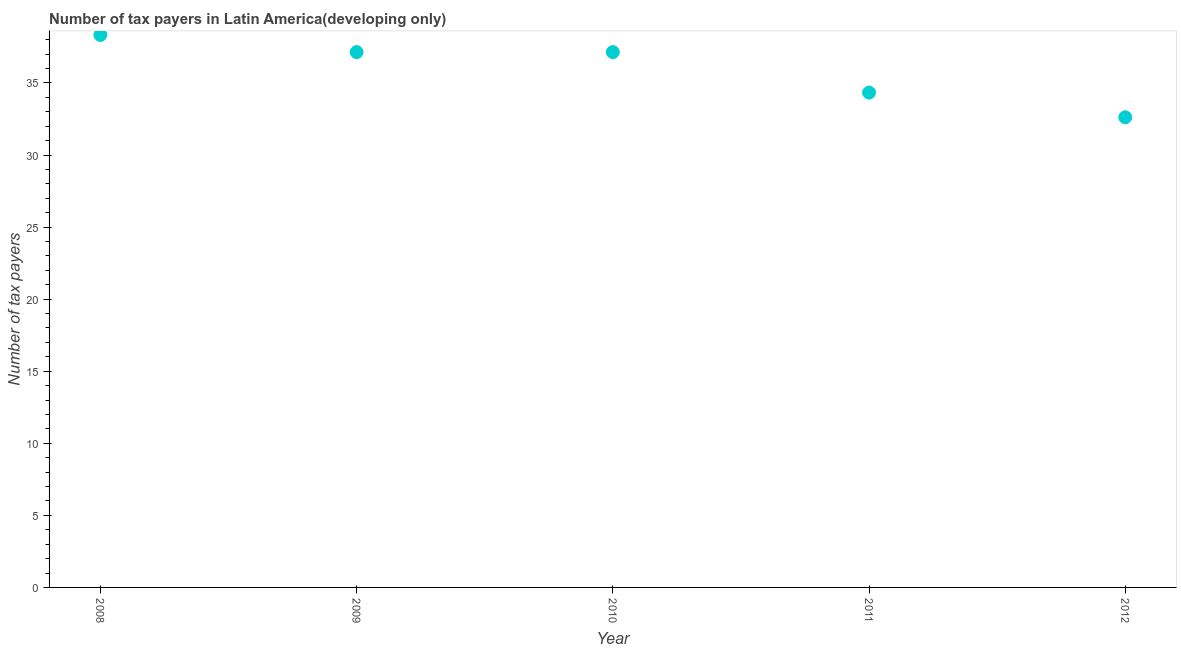What is the number of tax payers in 2012?
Provide a short and direct response. 32.62. Across all years, what is the maximum number of tax payers?
Your answer should be very brief. 38.33. Across all years, what is the minimum number of tax payers?
Keep it short and to the point. 32.62. In which year was the number of tax payers maximum?
Offer a terse response. 2008. In which year was the number of tax payers minimum?
Make the answer very short. 2012. What is the sum of the number of tax payers?
Provide a short and direct response. 179.57. What is the difference between the number of tax payers in 2009 and 2012?
Make the answer very short. 4.52. What is the average number of tax payers per year?
Provide a short and direct response. 35.91. What is the median number of tax payers?
Your answer should be very brief. 37.14. Do a majority of the years between 2012 and 2011 (inclusive) have number of tax payers greater than 10 ?
Your answer should be compact. No. What is the ratio of the number of tax payers in 2008 to that in 2012?
Your answer should be compact. 1.18. Is the difference between the number of tax payers in 2009 and 2012 greater than the difference between any two years?
Your answer should be very brief. No. What is the difference between the highest and the second highest number of tax payers?
Offer a very short reply. 1.19. Is the sum of the number of tax payers in 2008 and 2010 greater than the maximum number of tax payers across all years?
Ensure brevity in your answer.  Yes. What is the difference between the highest and the lowest number of tax payers?
Offer a very short reply. 5.71. In how many years, is the number of tax payers greater than the average number of tax payers taken over all years?
Your response must be concise. 3. How many dotlines are there?
Provide a short and direct response. 1. Does the graph contain any zero values?
Offer a terse response. No. What is the title of the graph?
Your response must be concise. Number of tax payers in Latin America(developing only). What is the label or title of the X-axis?
Your answer should be compact. Year. What is the label or title of the Y-axis?
Your answer should be compact. Number of tax payers. What is the Number of tax payers in 2008?
Your response must be concise. 38.33. What is the Number of tax payers in 2009?
Provide a succinct answer. 37.14. What is the Number of tax payers in 2010?
Provide a short and direct response. 37.14. What is the Number of tax payers in 2011?
Your answer should be compact. 34.33. What is the Number of tax payers in 2012?
Your response must be concise. 32.62. What is the difference between the Number of tax payers in 2008 and 2009?
Ensure brevity in your answer.  1.19. What is the difference between the Number of tax payers in 2008 and 2010?
Ensure brevity in your answer.  1.19. What is the difference between the Number of tax payers in 2008 and 2012?
Keep it short and to the point. 5.71. What is the difference between the Number of tax payers in 2009 and 2010?
Offer a very short reply. 0. What is the difference between the Number of tax payers in 2009 and 2011?
Ensure brevity in your answer.  2.81. What is the difference between the Number of tax payers in 2009 and 2012?
Ensure brevity in your answer.  4.52. What is the difference between the Number of tax payers in 2010 and 2011?
Ensure brevity in your answer.  2.81. What is the difference between the Number of tax payers in 2010 and 2012?
Offer a very short reply. 4.52. What is the difference between the Number of tax payers in 2011 and 2012?
Keep it short and to the point. 1.71. What is the ratio of the Number of tax payers in 2008 to that in 2009?
Your answer should be very brief. 1.03. What is the ratio of the Number of tax payers in 2008 to that in 2010?
Provide a short and direct response. 1.03. What is the ratio of the Number of tax payers in 2008 to that in 2011?
Provide a short and direct response. 1.12. What is the ratio of the Number of tax payers in 2008 to that in 2012?
Your answer should be compact. 1.18. What is the ratio of the Number of tax payers in 2009 to that in 2010?
Give a very brief answer. 1. What is the ratio of the Number of tax payers in 2009 to that in 2011?
Keep it short and to the point. 1.08. What is the ratio of the Number of tax payers in 2009 to that in 2012?
Your answer should be very brief. 1.14. What is the ratio of the Number of tax payers in 2010 to that in 2011?
Give a very brief answer. 1.08. What is the ratio of the Number of tax payers in 2010 to that in 2012?
Provide a short and direct response. 1.14. What is the ratio of the Number of tax payers in 2011 to that in 2012?
Offer a very short reply. 1.05. 